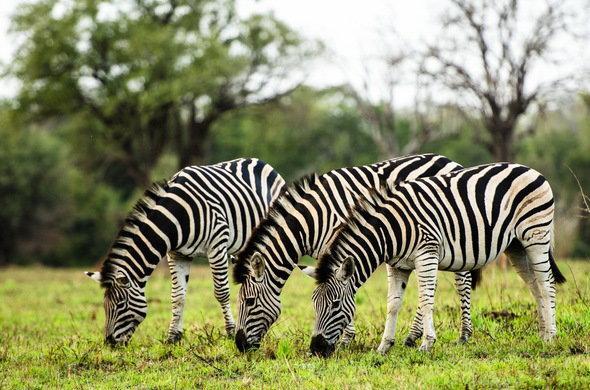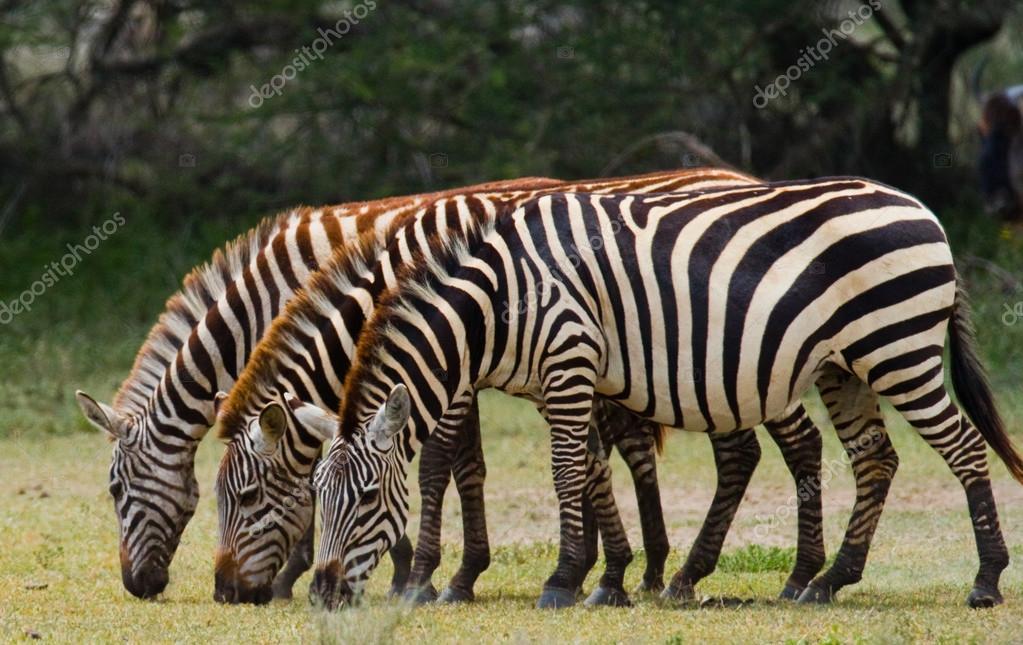The first image is the image on the left, the second image is the image on the right. For the images displayed, is the sentence "There are 6 zebras in total." factually correct? Answer yes or no. Yes. The first image is the image on the left, the second image is the image on the right. Given the left and right images, does the statement "Each image contains exactly three zebras, and the zebras in the right and left images face the same direction." hold true? Answer yes or no. Yes. 